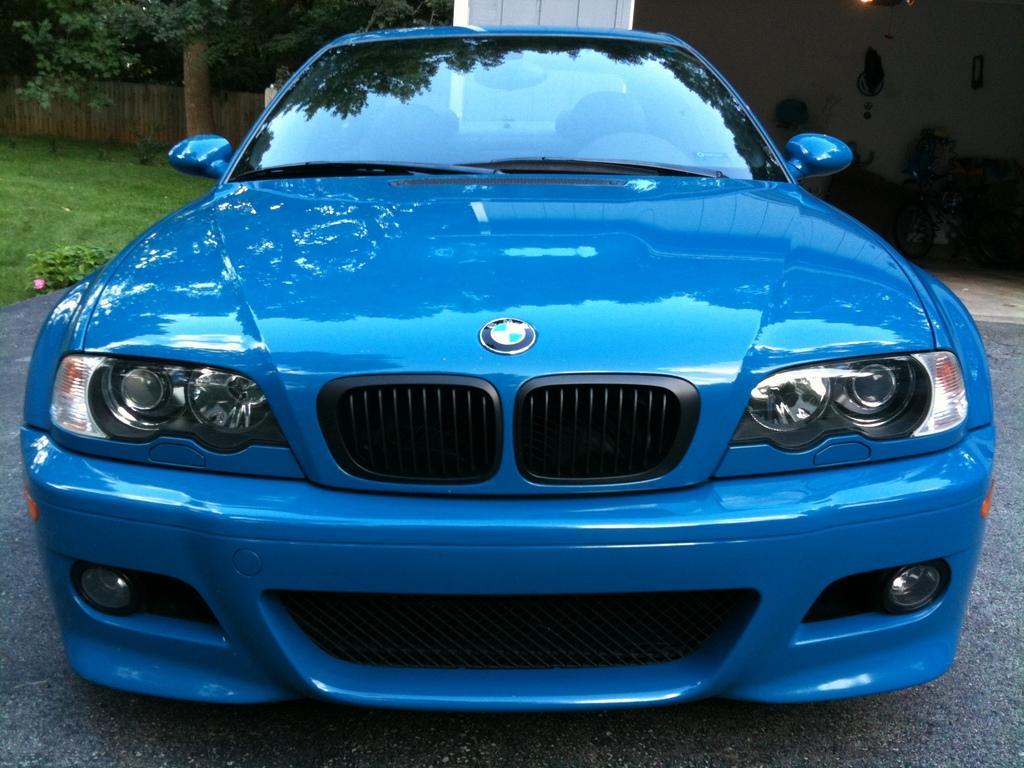Can you describe this image briefly? In this image I see a car which is of blue in color and I see the logo over here and I see the path. In the background I see the grass and I see the trees and I see the wooden fencing and I see the wall over here and I see few things over here. 